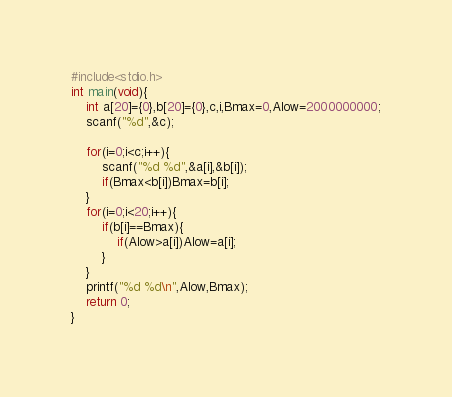Convert code to text. <code><loc_0><loc_0><loc_500><loc_500><_C_>#include<stdio.h>
int main(void){
    int a[20]={0},b[20]={0},c,i,Bmax=0,Alow=2000000000;
    scanf("%d",&c);

    for(i=0;i<c;i++){
        scanf("%d %d",&a[i],&b[i]);
        if(Bmax<b[i])Bmax=b[i];
    }
    for(i=0;i<20;i++){
        if(b[i]==Bmax){
            if(Alow>a[i])Alow=a[i];
        }
    }
    printf("%d %d\n",Alow,Bmax);
    return 0;
}</code> 